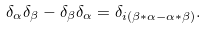<formula> <loc_0><loc_0><loc_500><loc_500>\delta _ { \alpha } \delta _ { \beta } - \delta _ { \beta } \delta _ { \alpha } = \delta _ { i ( \beta * \alpha - \alpha * \beta ) } .</formula> 